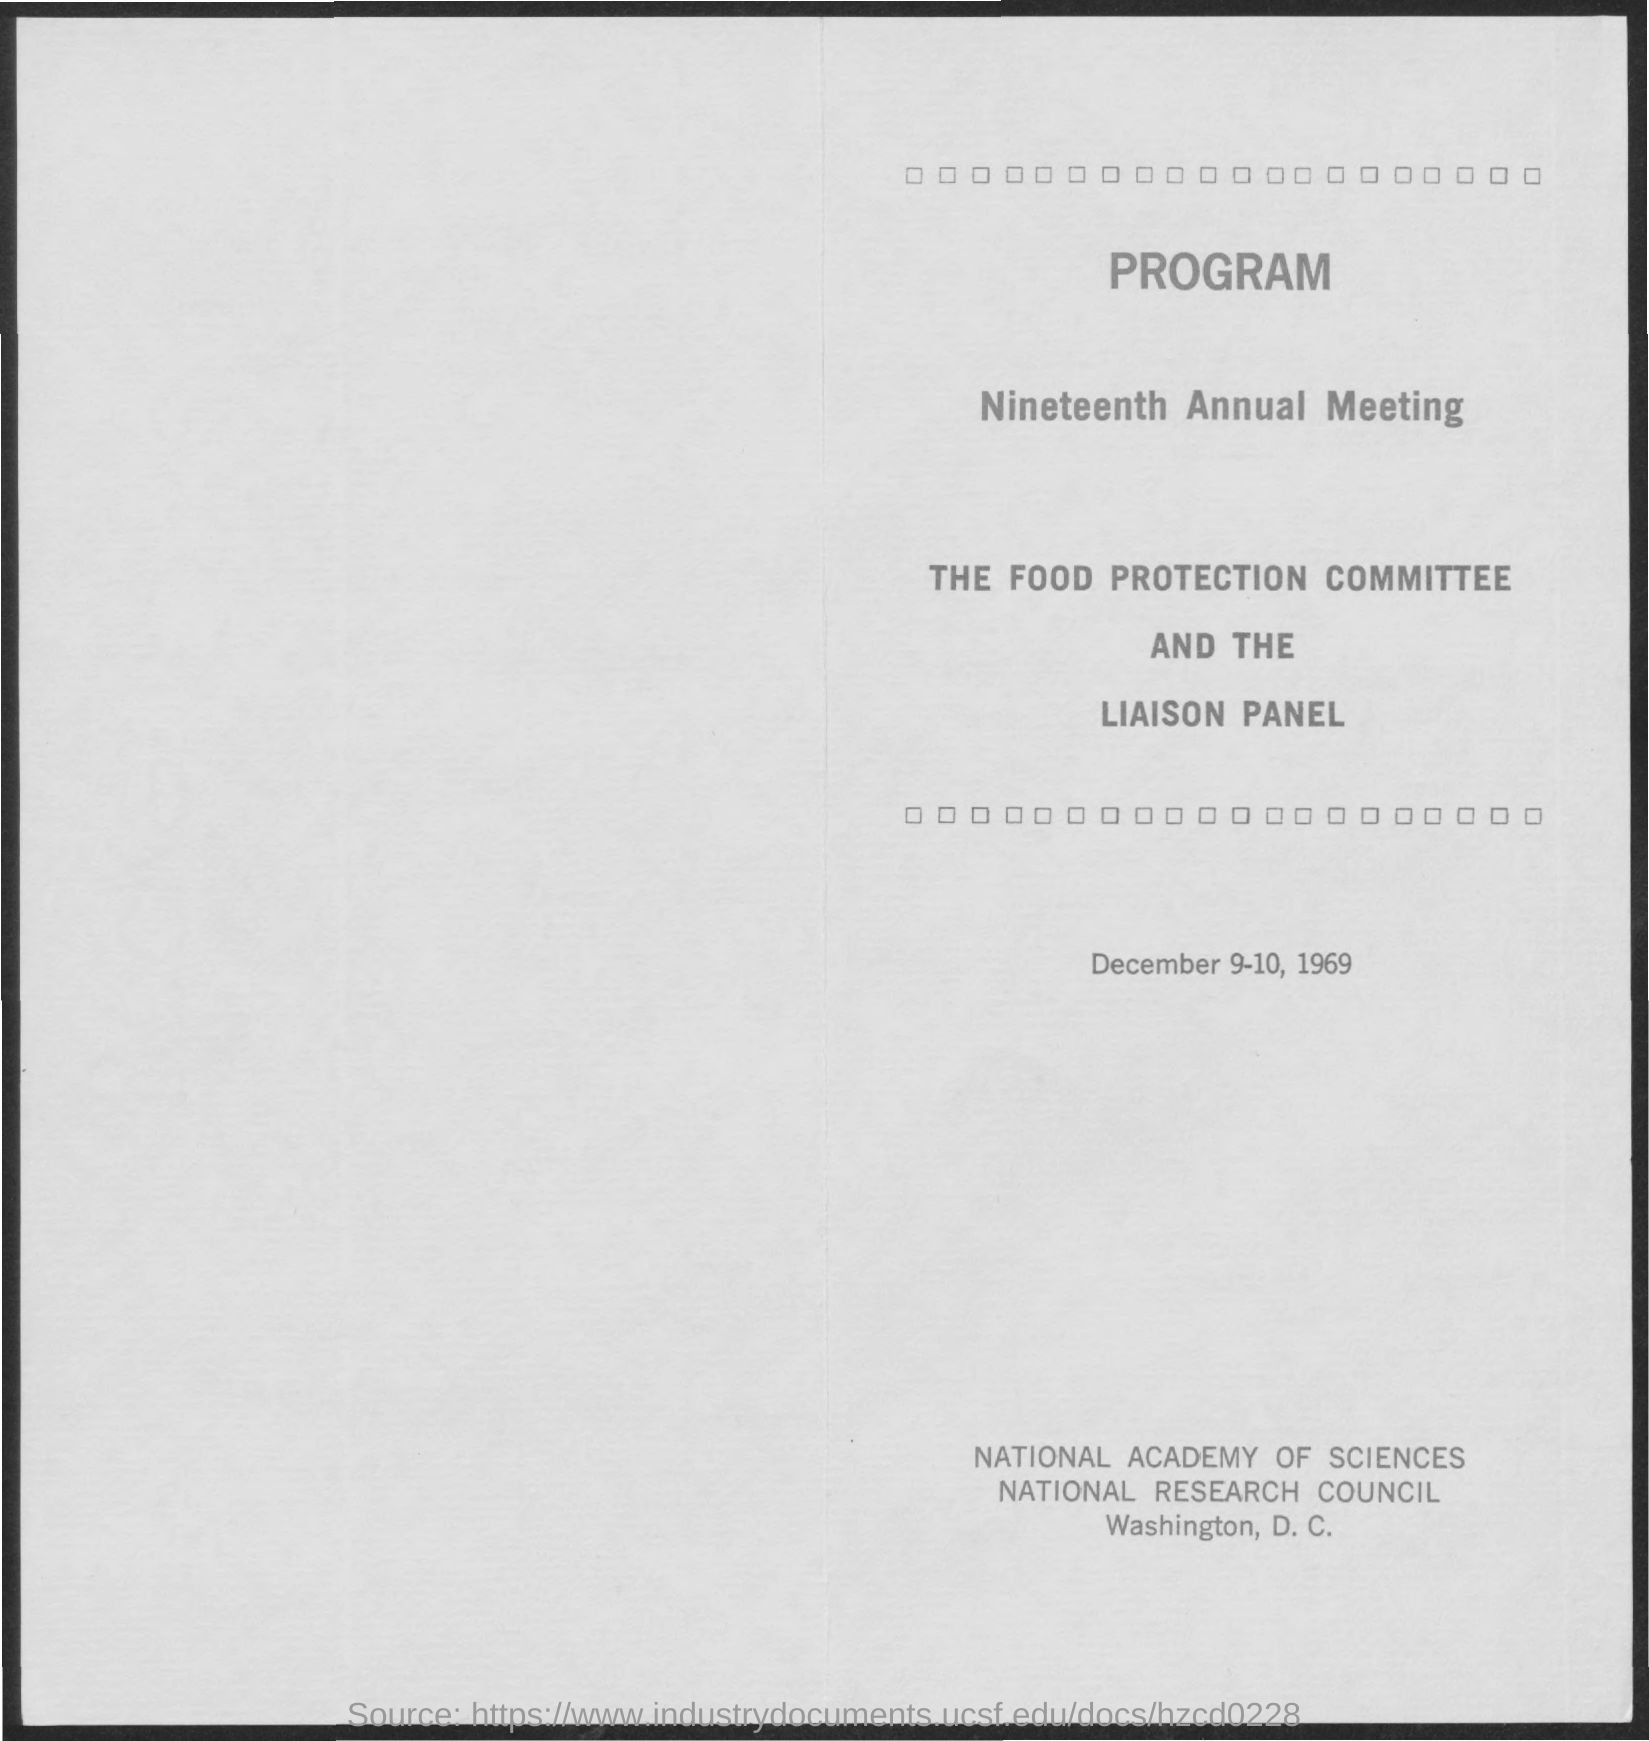When is the nineteenth annual meeting held?
Your answer should be very brief. December 9-10, 1969. 